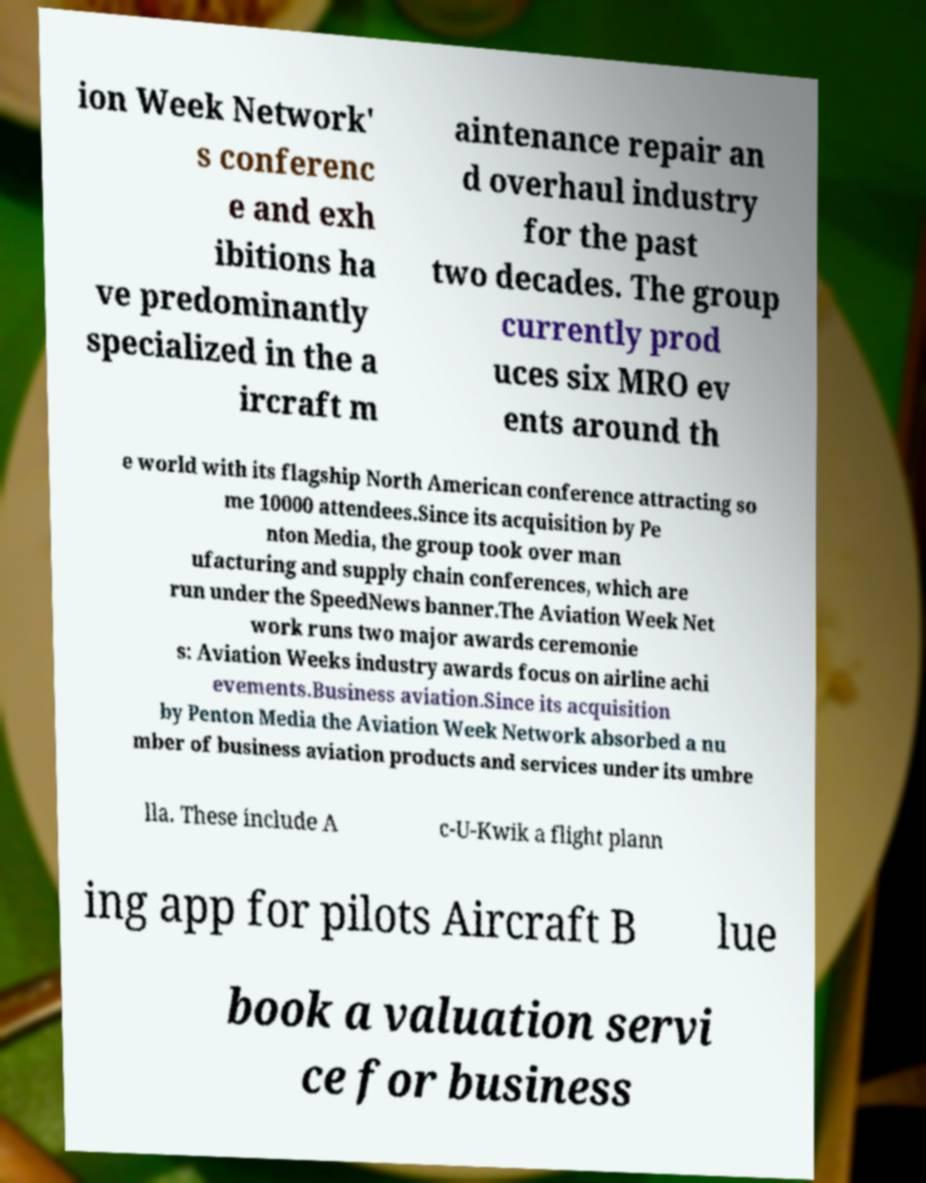Could you extract and type out the text from this image? ion Week Network' s conferenc e and exh ibitions ha ve predominantly specialized in the a ircraft m aintenance repair an d overhaul industry for the past two decades. The group currently prod uces six MRO ev ents around th e world with its flagship North American conference attracting so me 10000 attendees.Since its acquisition by Pe nton Media, the group took over man ufacturing and supply chain conferences, which are run under the SpeedNews banner.The Aviation Week Net work runs two major awards ceremonie s: Aviation Weeks industry awards focus on airline achi evements.Business aviation.Since its acquisition by Penton Media the Aviation Week Network absorbed a nu mber of business aviation products and services under its umbre lla. These include A c-U-Kwik a flight plann ing app for pilots Aircraft B lue book a valuation servi ce for business 